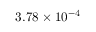Convert formula to latex. <formula><loc_0><loc_0><loc_500><loc_500>3 . 7 8 \times 1 0 ^ { - 4 }</formula> 